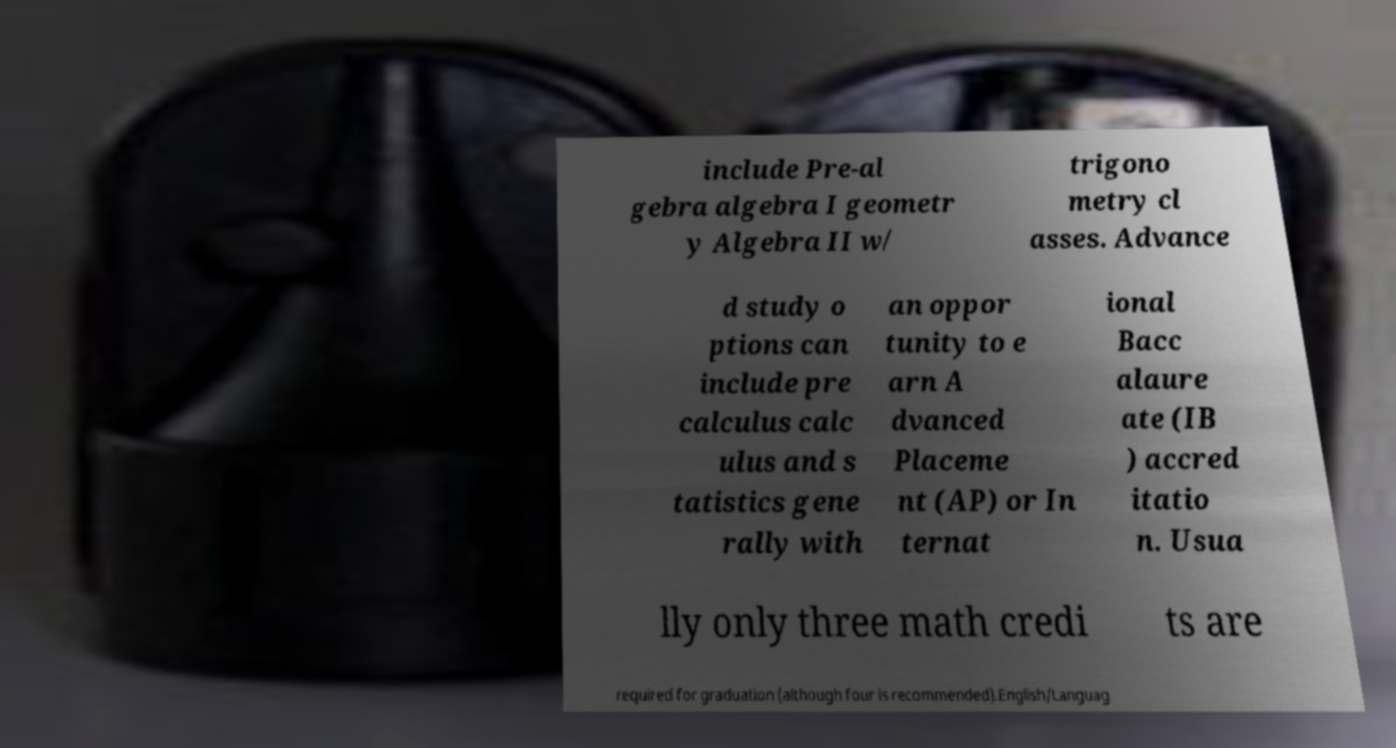What messages or text are displayed in this image? I need them in a readable, typed format. include Pre-al gebra algebra I geometr y Algebra II w/ trigono metry cl asses. Advance d study o ptions can include pre calculus calc ulus and s tatistics gene rally with an oppor tunity to e arn A dvanced Placeme nt (AP) or In ternat ional Bacc alaure ate (IB ) accred itatio n. Usua lly only three math credi ts are required for graduation (although four is recommended).English/Languag 